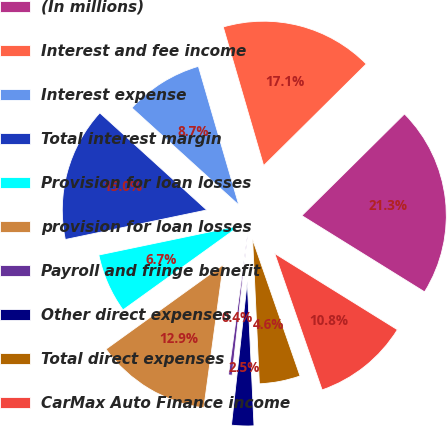Convert chart to OTSL. <chart><loc_0><loc_0><loc_500><loc_500><pie_chart><fcel>(In millions)<fcel>Interest and fee income<fcel>Interest expense<fcel>Total interest margin<fcel>Provision for loan losses<fcel>provision for loan losses<fcel>Payroll and fringe benefit<fcel>Other direct expenses<fcel>Total direct expenses<fcel>CarMax Auto Finance income<nl><fcel>21.27%<fcel>17.09%<fcel>8.75%<fcel>15.01%<fcel>6.66%<fcel>12.92%<fcel>0.4%<fcel>2.49%<fcel>4.58%<fcel>10.83%<nl></chart> 